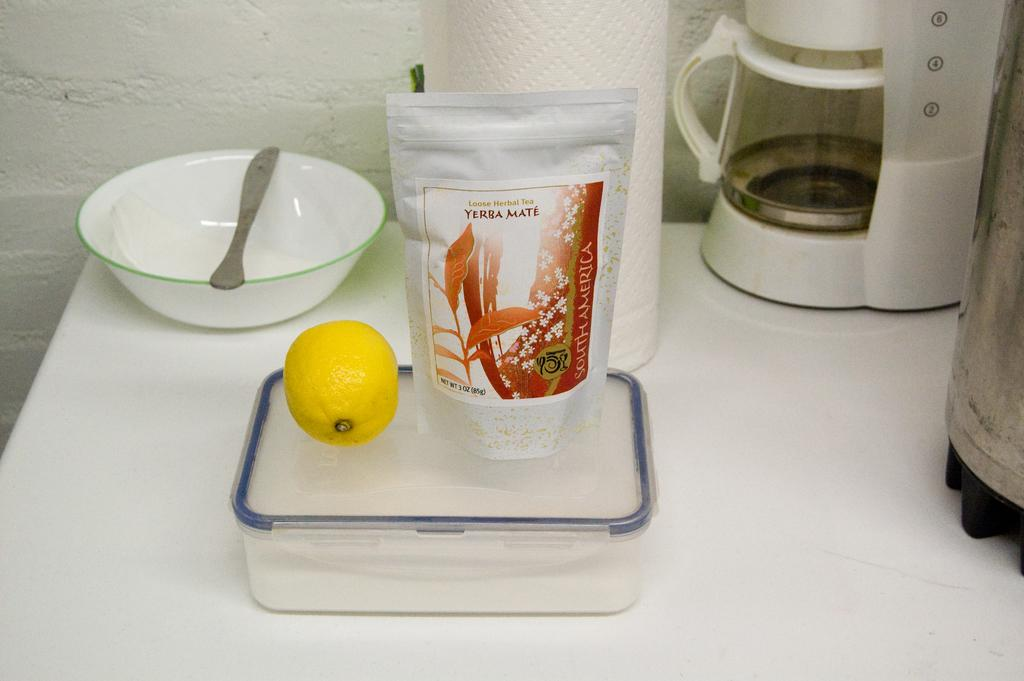<image>
Share a concise interpretation of the image provided. A package of Loose Herbal Tea by Yerba Mate sitting next to a lemon 